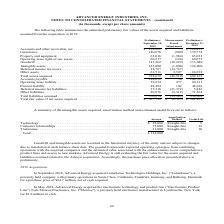According to Advanced Energy's financial document, What does the table show? summarizes the estimated preliminary fair values of the assets acquired and liabilities assumed from the acquisition in 2019. The document states: "The following table summarizes the estimated preliminary fair values of the assets acquired and liabilities assumed from the acquisition in 2019:..." Also, What was the Preliminary fair value of property and equipment in December 31, 2019? According to the financial document, 63,032 (in thousands). The relevant text states: ") 139,778 Property and equipment . 65,016 (1,984) 63,032 Operating lease right-of-use assets . 60,217 (144) 60,073 Goodwill . 143,262 (30,222) 113,040 Intan..." Also, What was the Preliminary fair value of inventories in September 10, 2019? According to the financial document, 140,678 (in thousands). The relevant text states: "Inventories . 140,678 (900) 139,778 Property and equipment . 65,016 (1,984) 63,032 Operating lease right-of-use assets ...." Also, can you calculate: What was the Preliminary percentage change of total liabilities assumed between September and December 2019? To answer this question, I need to perform calculations using the financial data. The calculation is: (330,909-370,874)/370,874, which equals -10.78 (percentage). This is based on the information: ",564 Total liabilities assumed . 370,874 (39,965) 330,909 Total fair value of net assets acquired . $ 367,798 $ (6,545) $ 361,253 80,876 (9,312) 71,564 Total liabilities assumed . 370,874 (39,965) 330..." The key data points involved are: 330,909, 370,874. Also, can you calculate: What was the Preliminary percentage change of total fair value of net assets acquired between September and December 2019? To answer this question, I need to perform calculations using the financial data. The calculation is: ($361,253-$367,798)/$367,798, which equals -1.78 (percentage). This is based on the information: "0,909 Total fair value of net assets acquired . $ 367,798 $ (6,545) $ 361,253 ue of net assets acquired . $ 367,798 $ (6,545) $ 361,253..." The key data points involved are: 361,253, 367,798. Also, can you calculate: What was the Preliminary percentage change of other liabilities between September and December 2019? To answer this question, I need to perform calculations using the financial data. The calculation is: (71,564-80,876)/80,876, which equals -11.51 (percentage). This is based on the information: "ities . 37,218 (31,372) 5,846 Other liabilities . 80,876 (9,312) 71,564 Total liabilities assumed . 370,874 (39,965) 330,909 Total fair value of net assets (31,372) 5,846 Other liabilities . 80,876 (9..." The key data points involved are: 71,564, 80,876. 